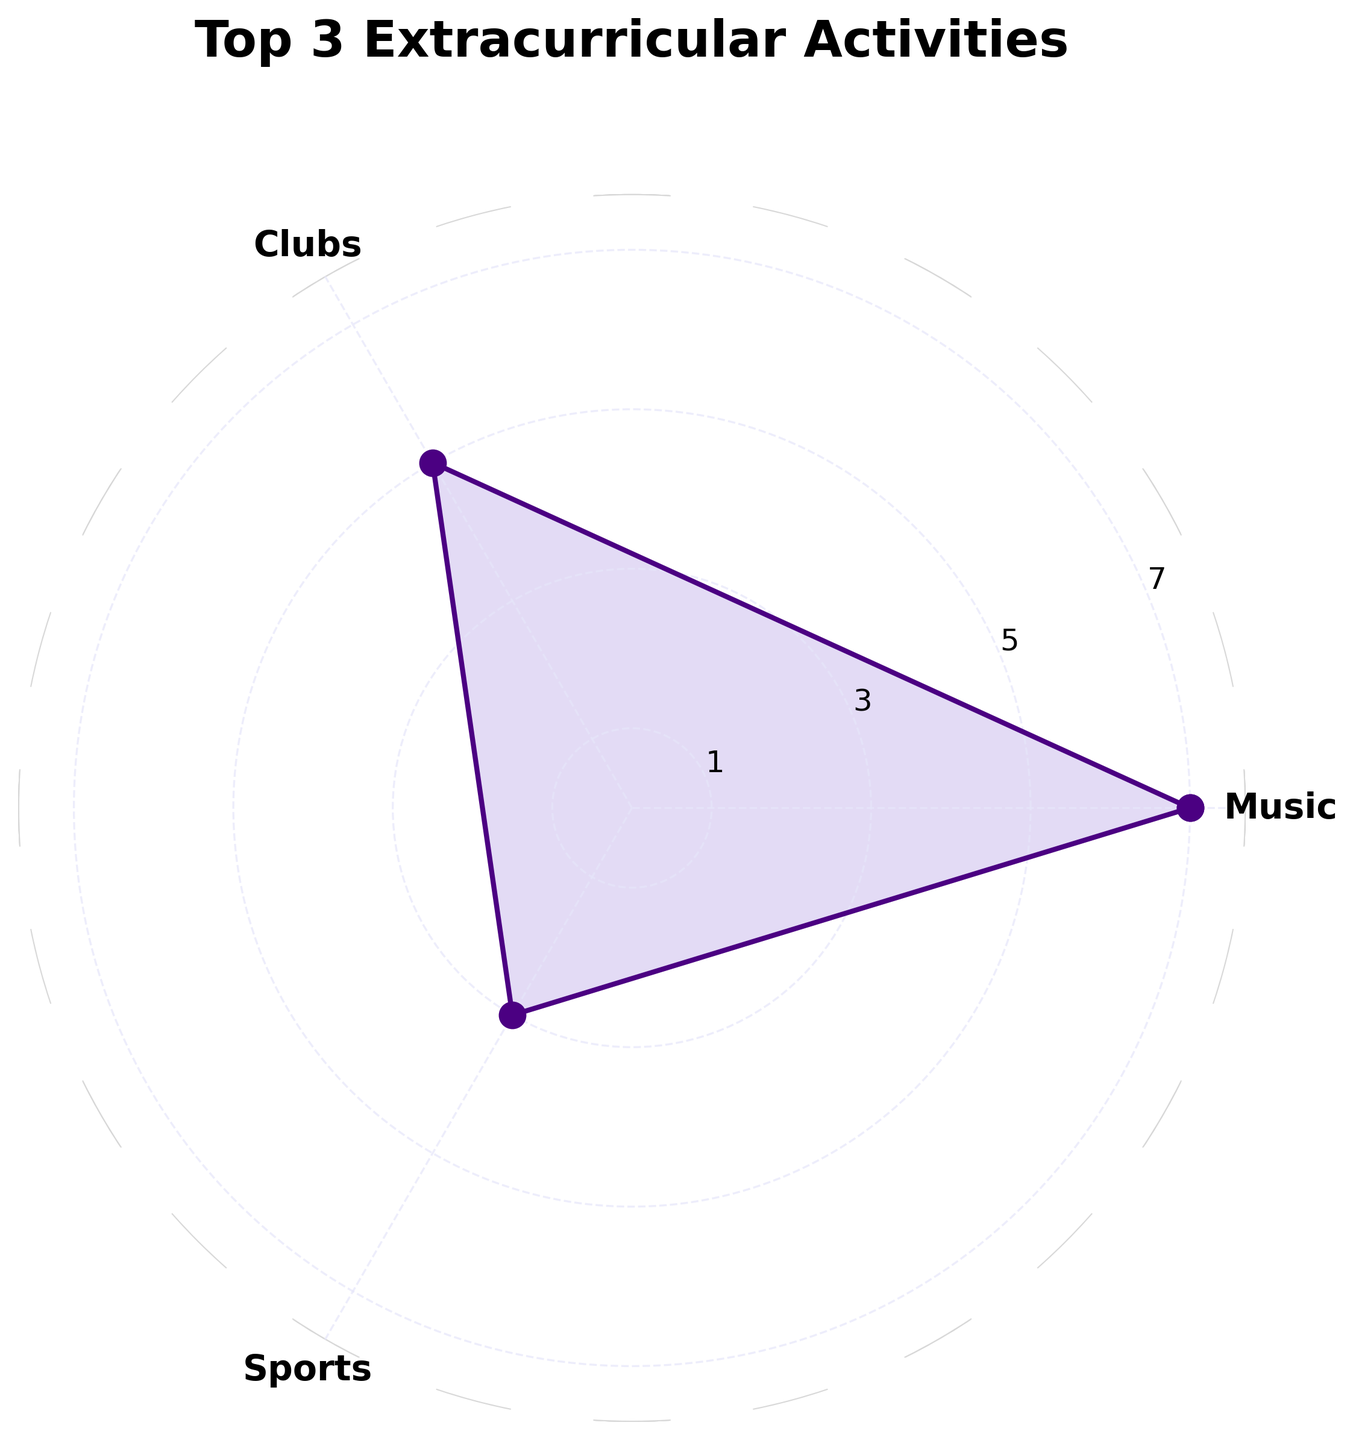What is the title of the rose chart? The title is displayed at the top of the chart, clearly marked in bold letters. It reads "Top 3 Extracurricular Activities"
Answer: Top 3 Extracurricular Activities Which activity has the highest frequency? By looking at the labels on the rose chart, Music has the longest segment, indicating it has the highest frequency.
Answer: Music What is the frequency of the activity with the lowest value? The lengths of the segments show the frequency, and Volunteering has the shortest segment, so its frequency is the lowest. The segment for Volunteering reaches to 2
Answer: 2 By how much does the frequency of Clubs exceed that of Volunteering? Clubs' segment is up to 5 while Volunteering's is 2. The difference between their frequencies is 5 - 2.
Answer: 3 What are the three activities shown in the rose chart? The labels around the chart list the activities. They are Music, Clubs, and Volunteering.
Answer: Music, Clubs, Volunteering Among the displayed activities, which has the second-highest frequency? Music has the highest frequency. Clubs has the next longest segment, making it the second-highest at 5.
Answer: Clubs What is the total combined frequency of all displayed activities? Adding the frequencies of Music (7), Clubs (5), and Volunteering (2) gives us the total: 7 + 5 + 2
Answer: 14 How many more times does Music occur compared to Volunteering? Music's frequency is 7, and Volunteering's is 2. To find how many more times Music occurs, calculate 7 / 2
Answer: 3.5 Are the extracurricular activities equally spaced around the chart? The angles between labels (each segment) show them evenly distributed, which indicates equal spacing around the chart.
Answer: Yes 